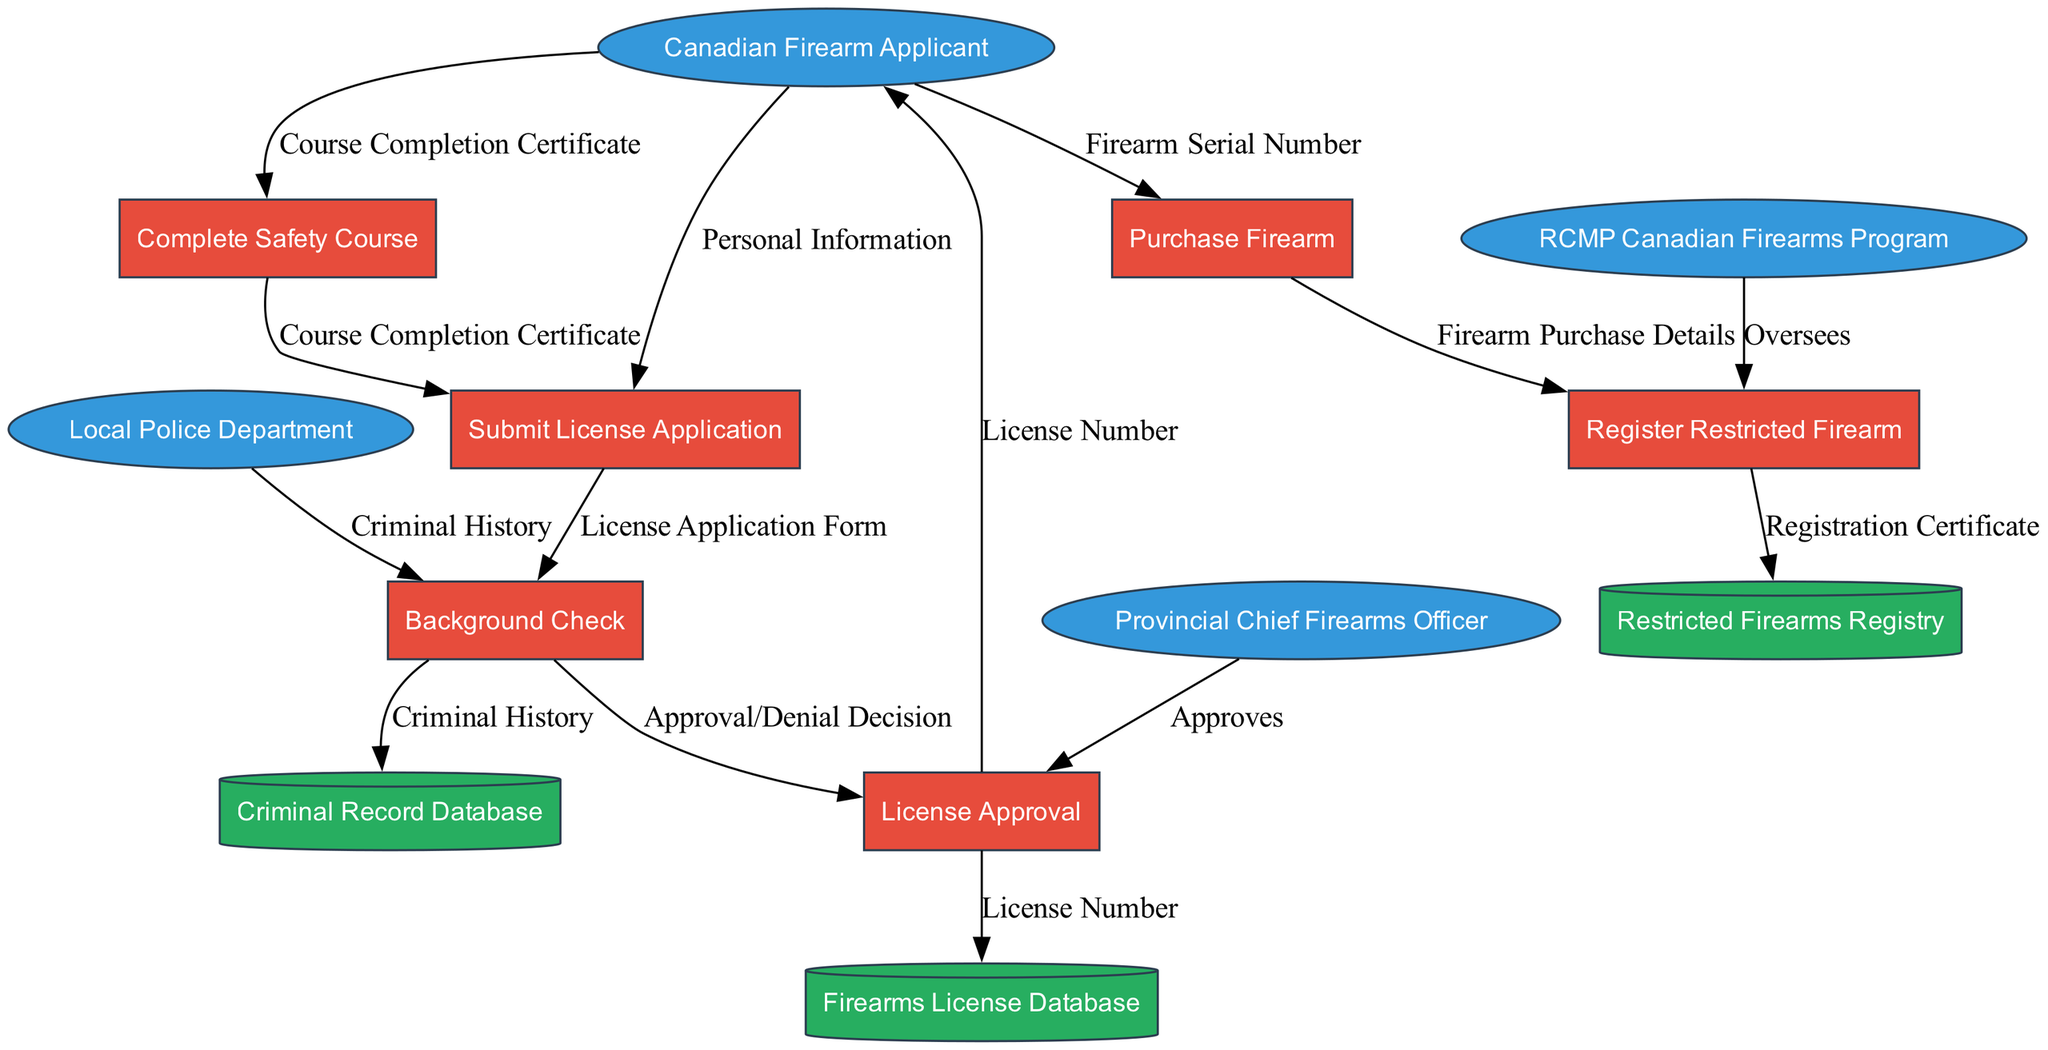What are the external entities involved in the process? The diagram outlines four external entities: Canadian Firearm Applicant, RCMP Canadian Firearms Program, Provincial Chief Firearms Officer, and Local Police Department. Thus, they collectively represent the organizations or individuals that interact with the firearm acquisition process.
Answer: Canadian Firearm Applicant, RCMP Canadian Firearms Program, Provincial Chief Firearms Officer, Local Police Department How many processes are defined in the diagram? There are six processes identified in the diagram: Complete Safety Course, Submit License Application, Background Check, License Approval, Purchase Firearm, and Register Restricted Firearm. By counting these, we find the total number of distinct processes.
Answer: 6 Which process follows the 'Submit License Application' step? From the diagram, after 'Submit License Application', the next step is 'Background Check'. The flow indicates a direct progression from the application submission to the initiation of the background check.
Answer: Background Check What is the data flow from the 'Complete Safety Course' to 'Submit License Application'? The diagram shows a data flow labeled 'Course Completion Certificate' moving from 'Complete Safety Course' to 'Submit License Application', indicating that the completion certificate is a required input for the application.
Answer: Course Completion Certificate Who is responsible for the 'License Approval' process? The 'Provincial Chief Firearms Officer' is responsible for the 'License Approval' process, as indicated in the diagram that shows a direct oversight relationship. This means they are the approving authority in this process.
Answer: Provincial Chief Firearms Officer What is registered as a result of the 'Register Restricted Firearm' process? The output of the 'Register Restricted Firearm' process is a 'Registration Certificate'. This indicates that the completion of the registration results in the issuance of a formal certificate representing the registration of the firearm.
Answer: Registration Certificate What is the connection between 'Background Check' and 'Criminal Record Database'? The flow of data indicates that the 'Background Check' process pulls information from the 'Criminal Record Database' to assess the criminal history of the applicant, which is essential for the decision-making process regarding license approval.
Answer: Criminal Record Database Which entity oversees the 'Register Restricted Firearm' process? The diagram specifies that the 'RCMP Canadian Firearms Program' oversees the 'Register Restricted Firearm' process, indicating their role in the regulation of firearm registration and related compliance.
Answer: RCMP Canadian Firearms Program 